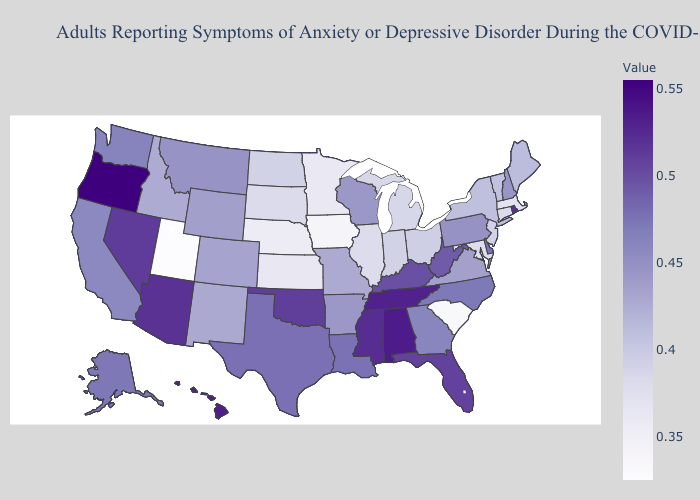Does Colorado have the highest value in the West?
Answer briefly. No. 